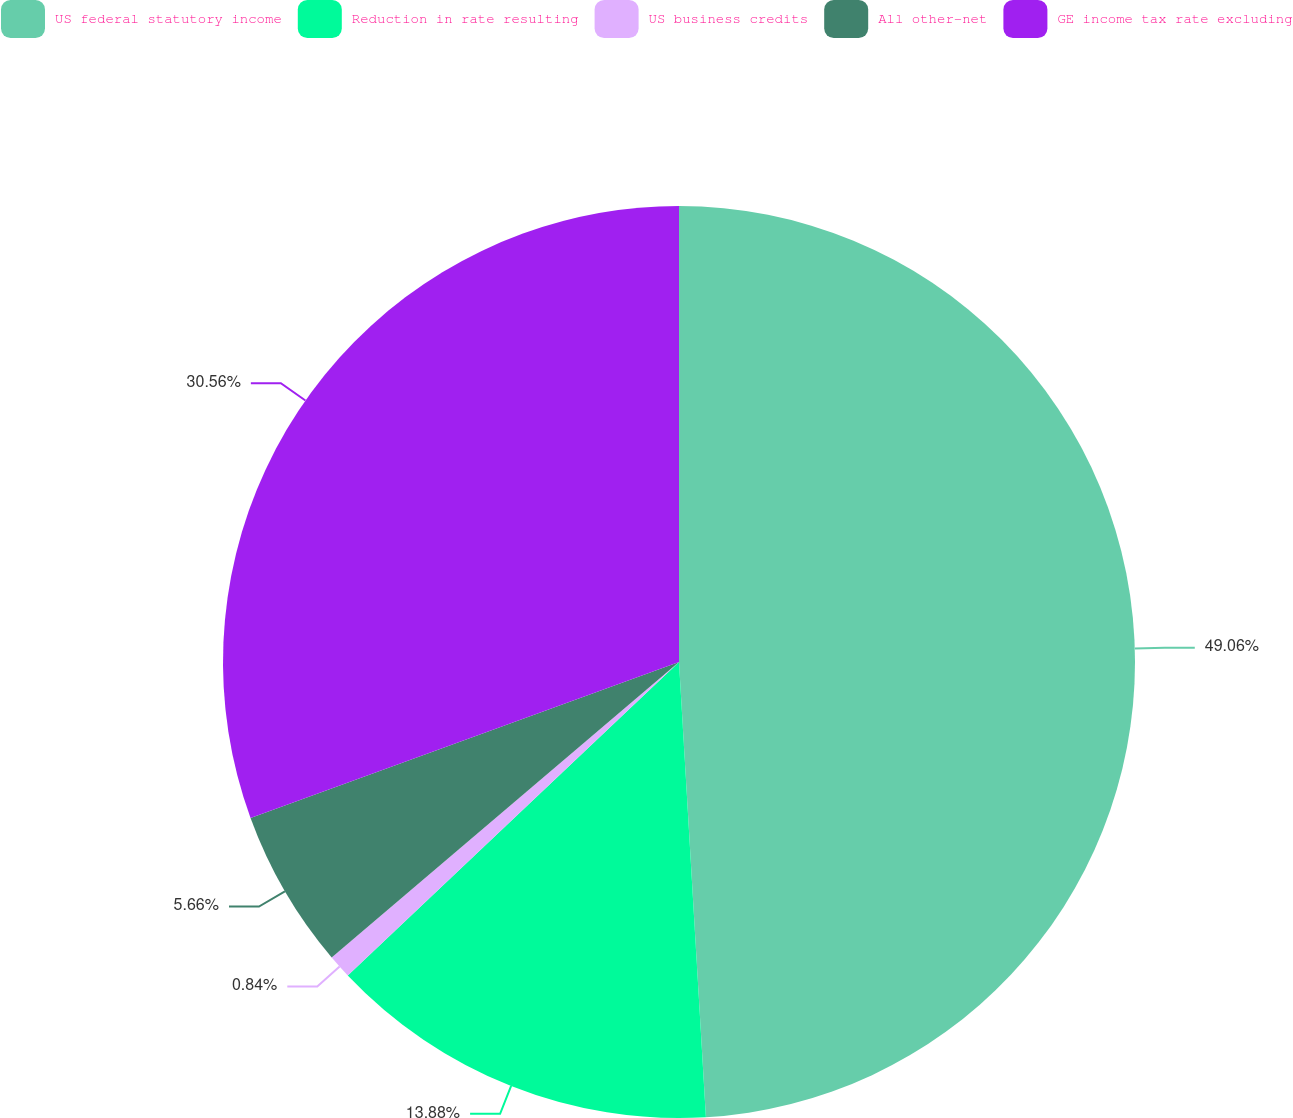<chart> <loc_0><loc_0><loc_500><loc_500><pie_chart><fcel>US federal statutory income<fcel>Reduction in rate resulting<fcel>US business credits<fcel>All other-net<fcel>GE income tax rate excluding<nl><fcel>49.06%<fcel>13.88%<fcel>0.84%<fcel>5.66%<fcel>30.56%<nl></chart> 